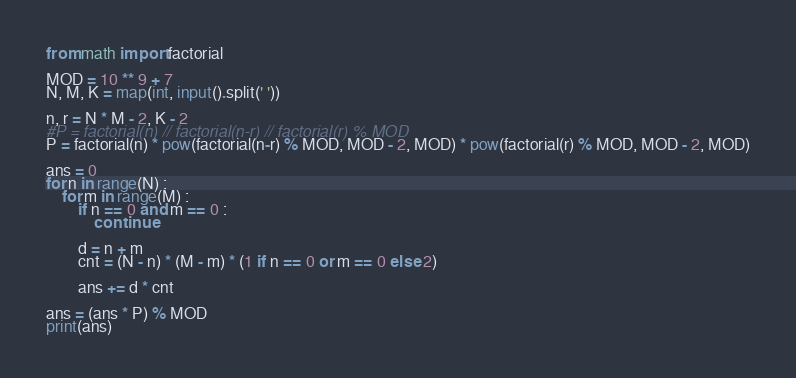<code> <loc_0><loc_0><loc_500><loc_500><_Python_>from math import factorial

MOD = 10 ** 9 + 7
N, M, K = map(int, input().split(' '))

n, r = N * M - 2, K - 2
#P = factorial(n) // factorial(n-r) // factorial(r) % MOD
P = factorial(n) * pow(factorial(n-r) % MOD, MOD - 2, MOD) * pow(factorial(r) % MOD, MOD - 2, MOD)

ans = 0
for n in range(N) :
    for m in range(M) :
        if n == 0 and m == 0 :
            continue

        d = n + m
        cnt = (N - n) * (M - m) * (1 if n == 0 or m == 0 else 2)

        ans += d * cnt

ans = (ans * P) % MOD
print(ans)
</code> 